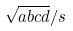Convert formula to latex. <formula><loc_0><loc_0><loc_500><loc_500>\sqrt { a b c d } / s</formula> 